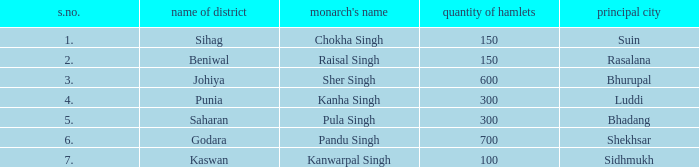What is the greatest s number with a capital of shekhsar? 6.0. 